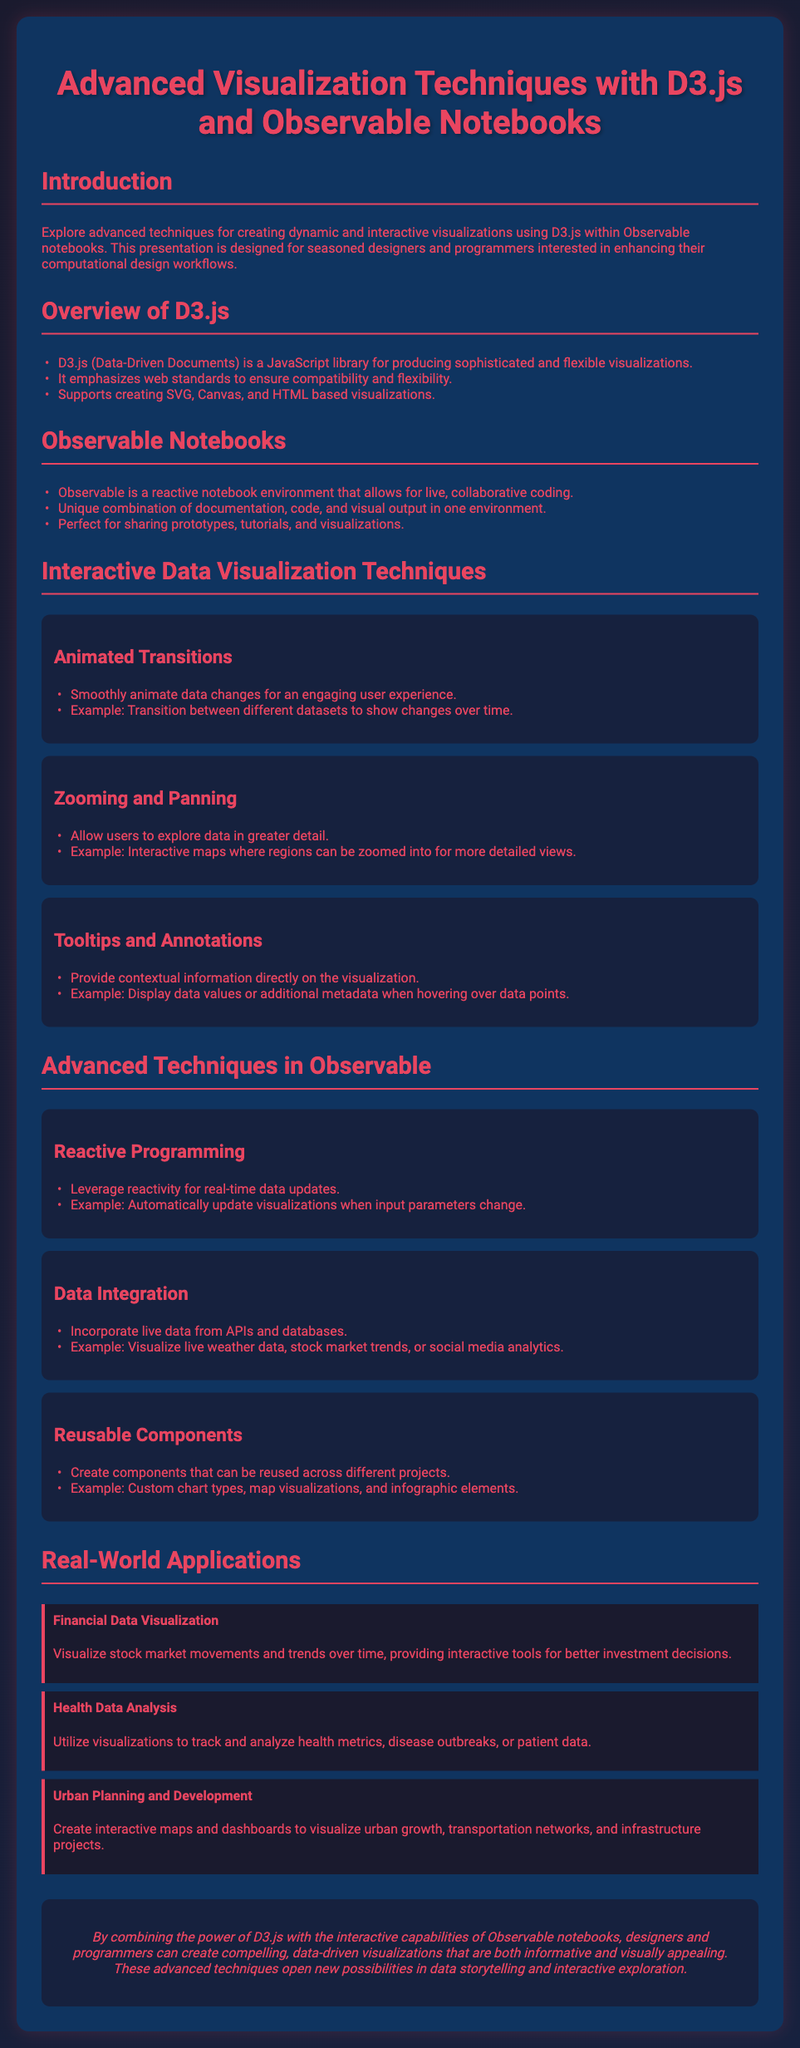What does D3.js stand for? D3.js stands for Data-Driven Documents, as mentioned in the overview section.
Answer: Data-Driven Documents What environment does Observable provide? Observable provides a reactive notebook environment for live, collaborative coding.
Answer: Reactive notebook What is one application of financial data visualization? Financial data visualization allows interactive tools for better investment decisions, as stated in the real-world applications section.
Answer: Investment decisions How many advanced techniques in Observable are mentioned? The section on advanced techniques lists three techniques: Reactive Programming, Data Integration, and Reusable Components.
Answer: Three What color is specified for the background of the container in the CSS? The background color for the container is #0f3460, as specified in the style section.
Answer: #0f3460 How can users explore data in more detail according to the techniques section? Users can explore data in greater detail through Zooming and Panning capabilities.
Answer: Zooming and Panning What is a benefit of using D3.js mentioned in the document? D3.js emphasizes web standards to ensure compatibility and flexibility, as per the overview.
Answer: Compatibility and flexibility Which programming paradigm does Observable enable for real-time updates? Observable enables Reactive Programming for real-time data updates.
Answer: Reactive Programming What type of analysis can health data visualizations assist with? Health data visualizations assist in tracking and analyzing health metrics and disease outbreaks.
Answer: Health metrics and disease outbreaks 